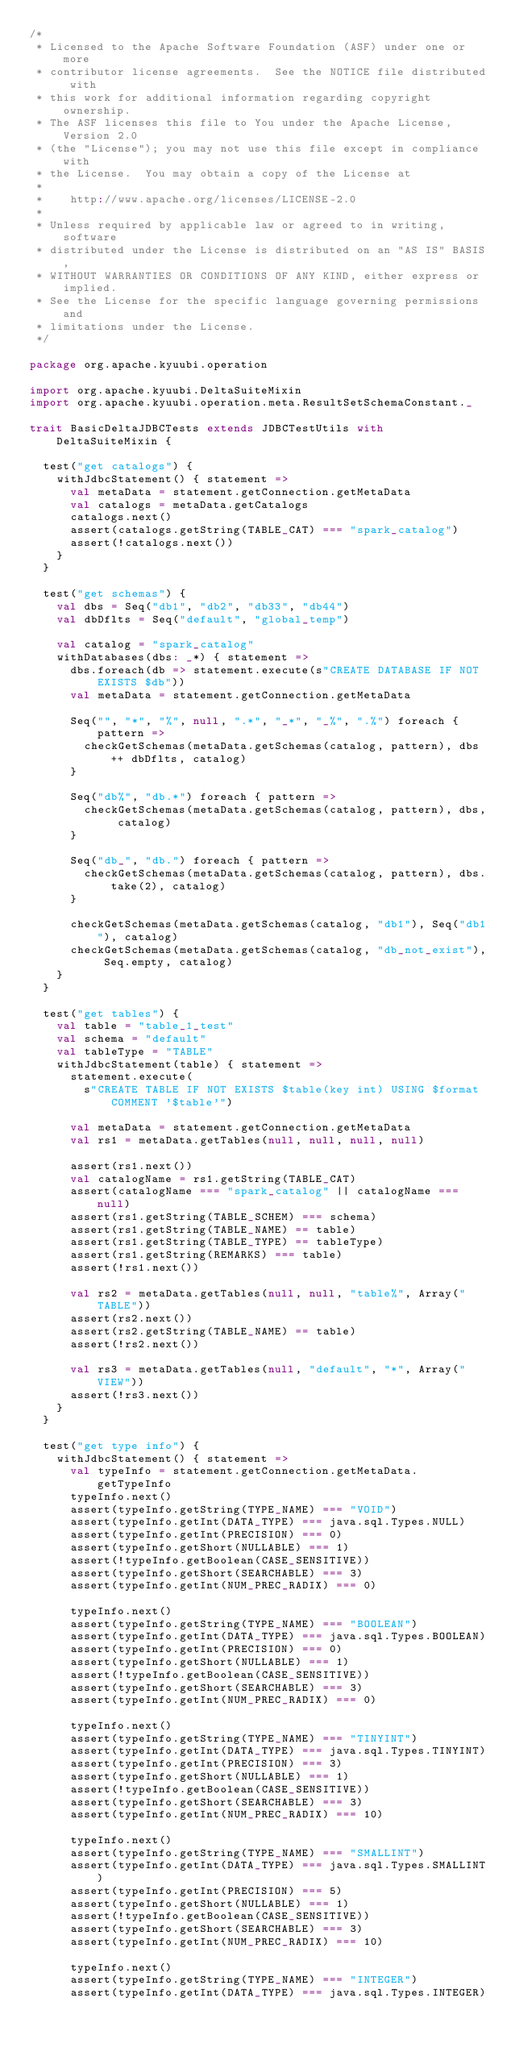Convert code to text. <code><loc_0><loc_0><loc_500><loc_500><_Scala_>/*
 * Licensed to the Apache Software Foundation (ASF) under one or more
 * contributor license agreements.  See the NOTICE file distributed with
 * this work for additional information regarding copyright ownership.
 * The ASF licenses this file to You under the Apache License, Version 2.0
 * (the "License"); you may not use this file except in compliance with
 * the License.  You may obtain a copy of the License at
 *
 *    http://www.apache.org/licenses/LICENSE-2.0
 *
 * Unless required by applicable law or agreed to in writing, software
 * distributed under the License is distributed on an "AS IS" BASIS,
 * WITHOUT WARRANTIES OR CONDITIONS OF ANY KIND, either express or implied.
 * See the License for the specific language governing permissions and
 * limitations under the License.
 */

package org.apache.kyuubi.operation

import org.apache.kyuubi.DeltaSuiteMixin
import org.apache.kyuubi.operation.meta.ResultSetSchemaConstant._

trait BasicDeltaJDBCTests extends JDBCTestUtils with DeltaSuiteMixin {

  test("get catalogs") {
    withJdbcStatement() { statement =>
      val metaData = statement.getConnection.getMetaData
      val catalogs = metaData.getCatalogs
      catalogs.next()
      assert(catalogs.getString(TABLE_CAT) === "spark_catalog")
      assert(!catalogs.next())
    }
  }

  test("get schemas") {
    val dbs = Seq("db1", "db2", "db33", "db44")
    val dbDflts = Seq("default", "global_temp")

    val catalog = "spark_catalog"
    withDatabases(dbs: _*) { statement =>
      dbs.foreach(db => statement.execute(s"CREATE DATABASE IF NOT EXISTS $db"))
      val metaData = statement.getConnection.getMetaData

      Seq("", "*", "%", null, ".*", "_*", "_%", ".%") foreach { pattern =>
        checkGetSchemas(metaData.getSchemas(catalog, pattern), dbs ++ dbDflts, catalog)
      }

      Seq("db%", "db.*") foreach { pattern =>
        checkGetSchemas(metaData.getSchemas(catalog, pattern), dbs, catalog)
      }

      Seq("db_", "db.") foreach { pattern =>
        checkGetSchemas(metaData.getSchemas(catalog, pattern), dbs.take(2), catalog)
      }

      checkGetSchemas(metaData.getSchemas(catalog, "db1"), Seq("db1"), catalog)
      checkGetSchemas(metaData.getSchemas(catalog, "db_not_exist"), Seq.empty, catalog)
    }
  }

  test("get tables") {
    val table = "table_1_test"
    val schema = "default"
    val tableType = "TABLE"
    withJdbcStatement(table) { statement =>
      statement.execute(
        s"CREATE TABLE IF NOT EXISTS $table(key int) USING $format COMMENT '$table'")

      val metaData = statement.getConnection.getMetaData
      val rs1 = metaData.getTables(null, null, null, null)

      assert(rs1.next())
      val catalogName = rs1.getString(TABLE_CAT)
      assert(catalogName === "spark_catalog" || catalogName === null)
      assert(rs1.getString(TABLE_SCHEM) === schema)
      assert(rs1.getString(TABLE_NAME) == table)
      assert(rs1.getString(TABLE_TYPE) == tableType)
      assert(rs1.getString(REMARKS) === table)
      assert(!rs1.next())

      val rs2 = metaData.getTables(null, null, "table%", Array("TABLE"))
      assert(rs2.next())
      assert(rs2.getString(TABLE_NAME) == table)
      assert(!rs2.next())

      val rs3 = metaData.getTables(null, "default", "*", Array("VIEW"))
      assert(!rs3.next())
    }
  }

  test("get type info") {
    withJdbcStatement() { statement =>
      val typeInfo = statement.getConnection.getMetaData.getTypeInfo
      typeInfo.next()
      assert(typeInfo.getString(TYPE_NAME) === "VOID")
      assert(typeInfo.getInt(DATA_TYPE) === java.sql.Types.NULL)
      assert(typeInfo.getInt(PRECISION) === 0)
      assert(typeInfo.getShort(NULLABLE) === 1)
      assert(!typeInfo.getBoolean(CASE_SENSITIVE))
      assert(typeInfo.getShort(SEARCHABLE) === 3)
      assert(typeInfo.getInt(NUM_PREC_RADIX) === 0)

      typeInfo.next()
      assert(typeInfo.getString(TYPE_NAME) === "BOOLEAN")
      assert(typeInfo.getInt(DATA_TYPE) === java.sql.Types.BOOLEAN)
      assert(typeInfo.getInt(PRECISION) === 0)
      assert(typeInfo.getShort(NULLABLE) === 1)
      assert(!typeInfo.getBoolean(CASE_SENSITIVE))
      assert(typeInfo.getShort(SEARCHABLE) === 3)
      assert(typeInfo.getInt(NUM_PREC_RADIX) === 0)

      typeInfo.next()
      assert(typeInfo.getString(TYPE_NAME) === "TINYINT")
      assert(typeInfo.getInt(DATA_TYPE) === java.sql.Types.TINYINT)
      assert(typeInfo.getInt(PRECISION) === 3)
      assert(typeInfo.getShort(NULLABLE) === 1)
      assert(!typeInfo.getBoolean(CASE_SENSITIVE))
      assert(typeInfo.getShort(SEARCHABLE) === 3)
      assert(typeInfo.getInt(NUM_PREC_RADIX) === 10)

      typeInfo.next()
      assert(typeInfo.getString(TYPE_NAME) === "SMALLINT")
      assert(typeInfo.getInt(DATA_TYPE) === java.sql.Types.SMALLINT)
      assert(typeInfo.getInt(PRECISION) === 5)
      assert(typeInfo.getShort(NULLABLE) === 1)
      assert(!typeInfo.getBoolean(CASE_SENSITIVE))
      assert(typeInfo.getShort(SEARCHABLE) === 3)
      assert(typeInfo.getInt(NUM_PREC_RADIX) === 10)

      typeInfo.next()
      assert(typeInfo.getString(TYPE_NAME) === "INTEGER")
      assert(typeInfo.getInt(DATA_TYPE) === java.sql.Types.INTEGER)</code> 